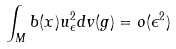<formula> <loc_0><loc_0><loc_500><loc_500>\int _ { M } b ( x ) u _ { \epsilon } ^ { 2 } d v ( g ) = o ( \epsilon ^ { 2 } )</formula> 